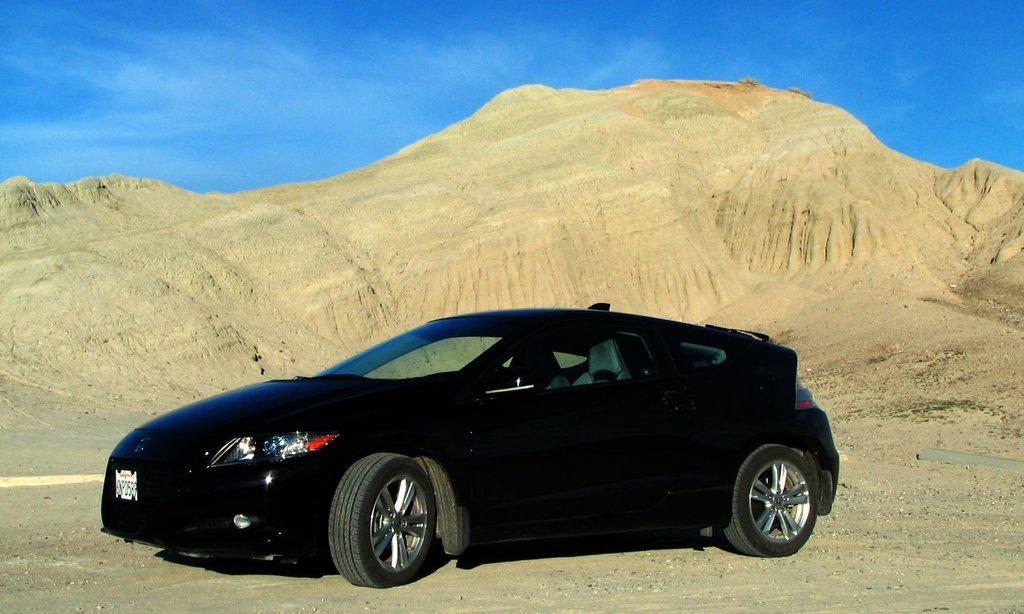What is the main subject of the image? There is a car in the image. Can you describe the color of the car? The car is black. What type of terrain is visible in the background of the image? There is sand in the background of the image. What color is the sand? The sand is brown. What part of the natural environment is visible in the image? The sky is visible in the image. What color is the sky? The sky is blue. Is there a beggar asking for money near the car in the image? There is no beggar present in the image; it only features a black car with a brown sandy background and a blue sky. What type of print can be seen on the car's hood in the image? There is no print visible on the car's hood in the image; it is a plain black car. 